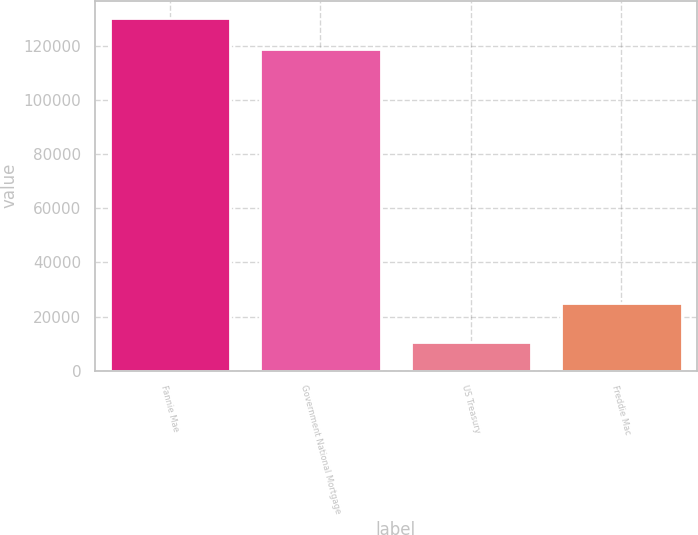Convert chart to OTSL. <chart><loc_0><loc_0><loc_500><loc_500><bar_chart><fcel>Fannie Mae<fcel>Government National Mortgage<fcel>US Treasury<fcel>Freddie Mac<nl><fcel>130028<fcel>118700<fcel>10533<fcel>24908<nl></chart> 